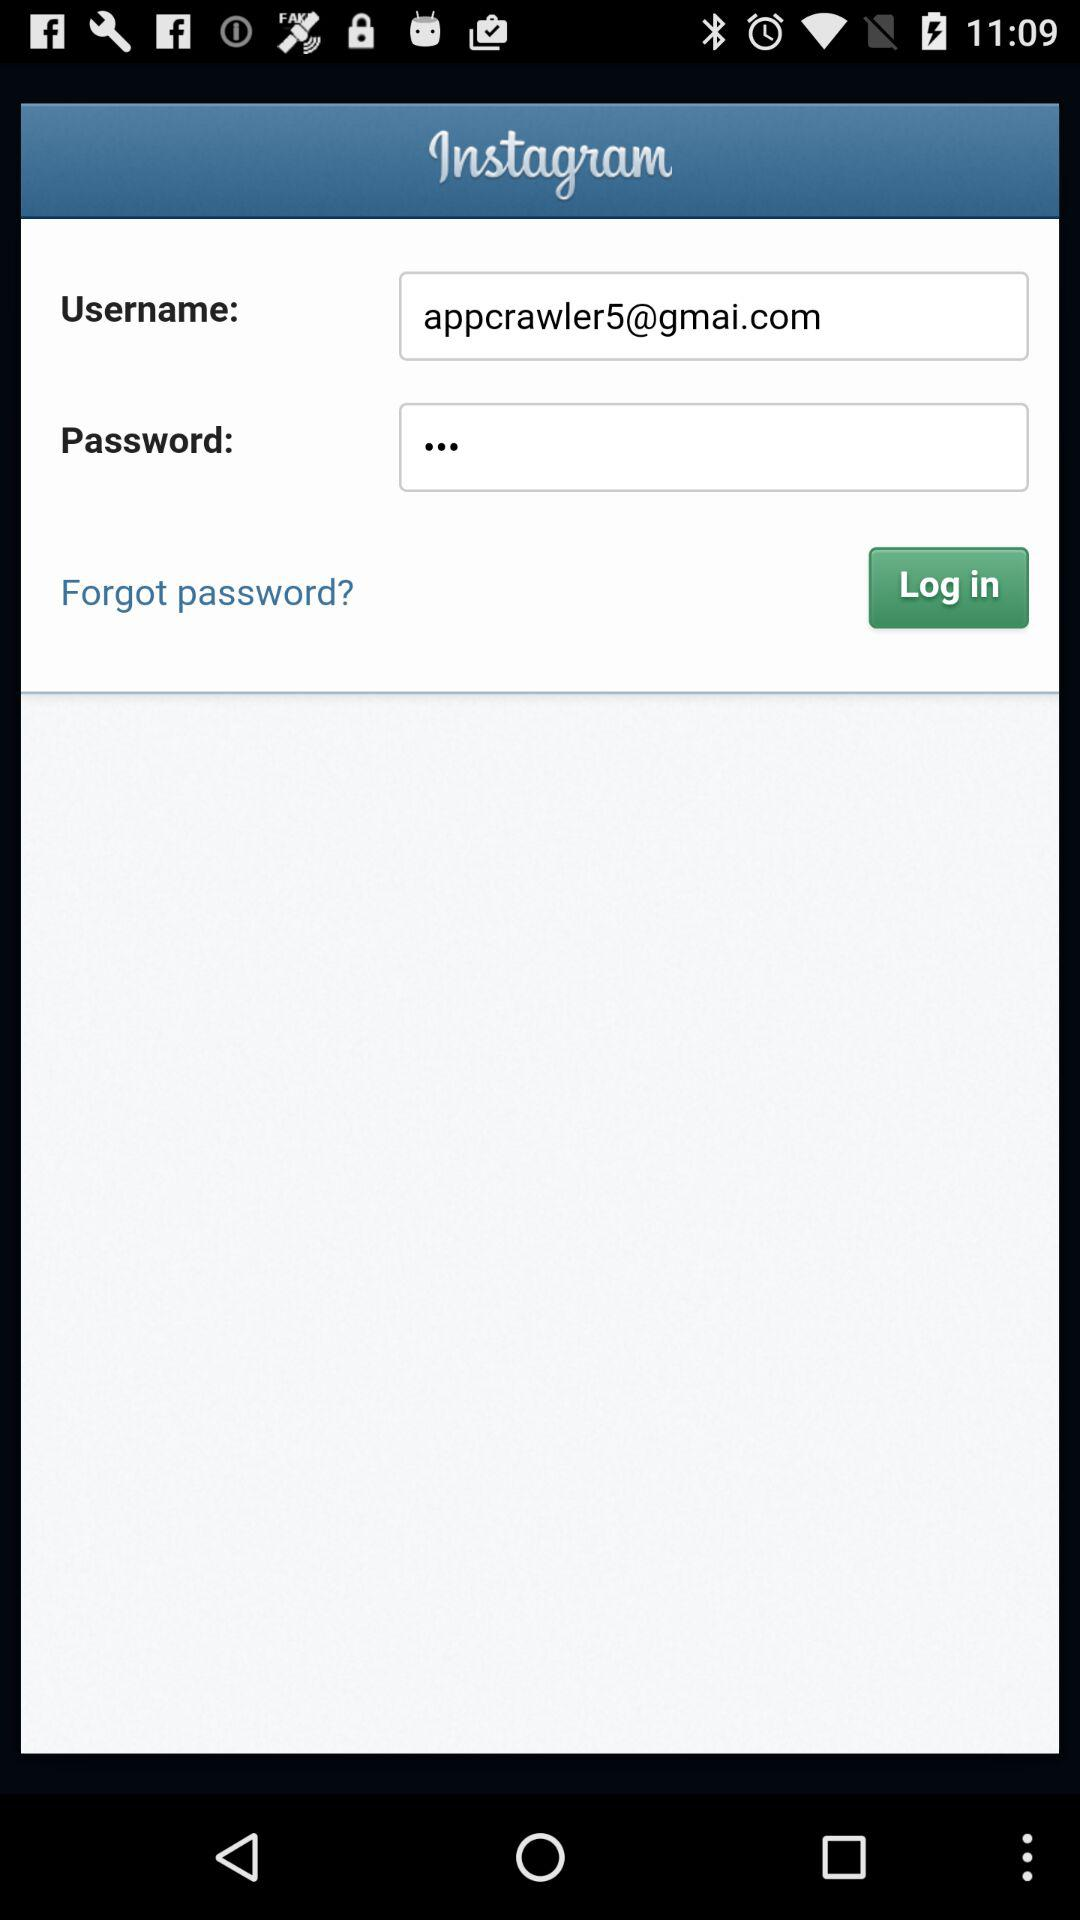What is the application name? The application name is "Instagram". 